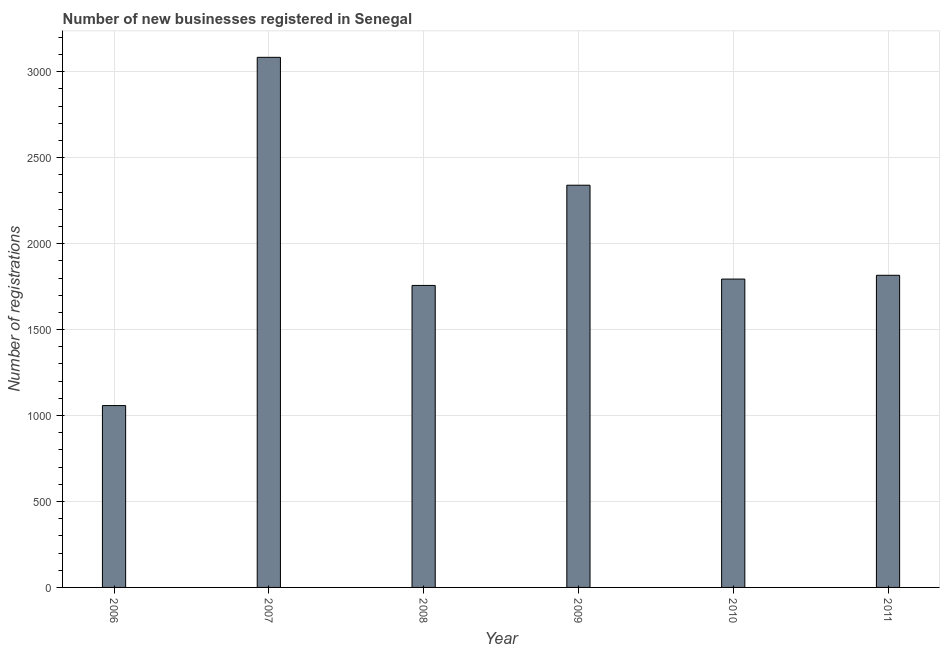What is the title of the graph?
Your answer should be very brief. Number of new businesses registered in Senegal. What is the label or title of the Y-axis?
Keep it short and to the point. Number of registrations. What is the number of new business registrations in 2006?
Give a very brief answer. 1058. Across all years, what is the maximum number of new business registrations?
Your answer should be very brief. 3084. Across all years, what is the minimum number of new business registrations?
Your answer should be very brief. 1058. What is the sum of the number of new business registrations?
Give a very brief answer. 1.18e+04. What is the difference between the number of new business registrations in 2006 and 2009?
Keep it short and to the point. -1282. What is the average number of new business registrations per year?
Offer a terse response. 1974. What is the median number of new business registrations?
Keep it short and to the point. 1805. What is the ratio of the number of new business registrations in 2007 to that in 2008?
Keep it short and to the point. 1.75. Is the difference between the number of new business registrations in 2010 and 2011 greater than the difference between any two years?
Your answer should be very brief. No. What is the difference between the highest and the second highest number of new business registrations?
Provide a succinct answer. 744. Is the sum of the number of new business registrations in 2009 and 2010 greater than the maximum number of new business registrations across all years?
Offer a terse response. Yes. What is the difference between the highest and the lowest number of new business registrations?
Make the answer very short. 2026. Are all the bars in the graph horizontal?
Offer a very short reply. No. How many years are there in the graph?
Provide a short and direct response. 6. What is the difference between two consecutive major ticks on the Y-axis?
Ensure brevity in your answer.  500. Are the values on the major ticks of Y-axis written in scientific E-notation?
Provide a succinct answer. No. What is the Number of registrations of 2006?
Your answer should be compact. 1058. What is the Number of registrations in 2007?
Make the answer very short. 3084. What is the Number of registrations of 2008?
Your answer should be very brief. 1757. What is the Number of registrations of 2009?
Ensure brevity in your answer.  2340. What is the Number of registrations in 2010?
Give a very brief answer. 1794. What is the Number of registrations in 2011?
Provide a succinct answer. 1816. What is the difference between the Number of registrations in 2006 and 2007?
Provide a succinct answer. -2026. What is the difference between the Number of registrations in 2006 and 2008?
Your answer should be compact. -699. What is the difference between the Number of registrations in 2006 and 2009?
Ensure brevity in your answer.  -1282. What is the difference between the Number of registrations in 2006 and 2010?
Your answer should be compact. -736. What is the difference between the Number of registrations in 2006 and 2011?
Your answer should be compact. -758. What is the difference between the Number of registrations in 2007 and 2008?
Give a very brief answer. 1327. What is the difference between the Number of registrations in 2007 and 2009?
Your response must be concise. 744. What is the difference between the Number of registrations in 2007 and 2010?
Make the answer very short. 1290. What is the difference between the Number of registrations in 2007 and 2011?
Make the answer very short. 1268. What is the difference between the Number of registrations in 2008 and 2009?
Provide a short and direct response. -583. What is the difference between the Number of registrations in 2008 and 2010?
Offer a terse response. -37. What is the difference between the Number of registrations in 2008 and 2011?
Your answer should be compact. -59. What is the difference between the Number of registrations in 2009 and 2010?
Give a very brief answer. 546. What is the difference between the Number of registrations in 2009 and 2011?
Your answer should be very brief. 524. What is the ratio of the Number of registrations in 2006 to that in 2007?
Offer a terse response. 0.34. What is the ratio of the Number of registrations in 2006 to that in 2008?
Keep it short and to the point. 0.6. What is the ratio of the Number of registrations in 2006 to that in 2009?
Ensure brevity in your answer.  0.45. What is the ratio of the Number of registrations in 2006 to that in 2010?
Provide a succinct answer. 0.59. What is the ratio of the Number of registrations in 2006 to that in 2011?
Offer a terse response. 0.58. What is the ratio of the Number of registrations in 2007 to that in 2008?
Provide a short and direct response. 1.75. What is the ratio of the Number of registrations in 2007 to that in 2009?
Provide a succinct answer. 1.32. What is the ratio of the Number of registrations in 2007 to that in 2010?
Keep it short and to the point. 1.72. What is the ratio of the Number of registrations in 2007 to that in 2011?
Your answer should be compact. 1.7. What is the ratio of the Number of registrations in 2008 to that in 2009?
Ensure brevity in your answer.  0.75. What is the ratio of the Number of registrations in 2008 to that in 2010?
Make the answer very short. 0.98. What is the ratio of the Number of registrations in 2009 to that in 2010?
Offer a terse response. 1.3. What is the ratio of the Number of registrations in 2009 to that in 2011?
Your response must be concise. 1.29. What is the ratio of the Number of registrations in 2010 to that in 2011?
Provide a short and direct response. 0.99. 